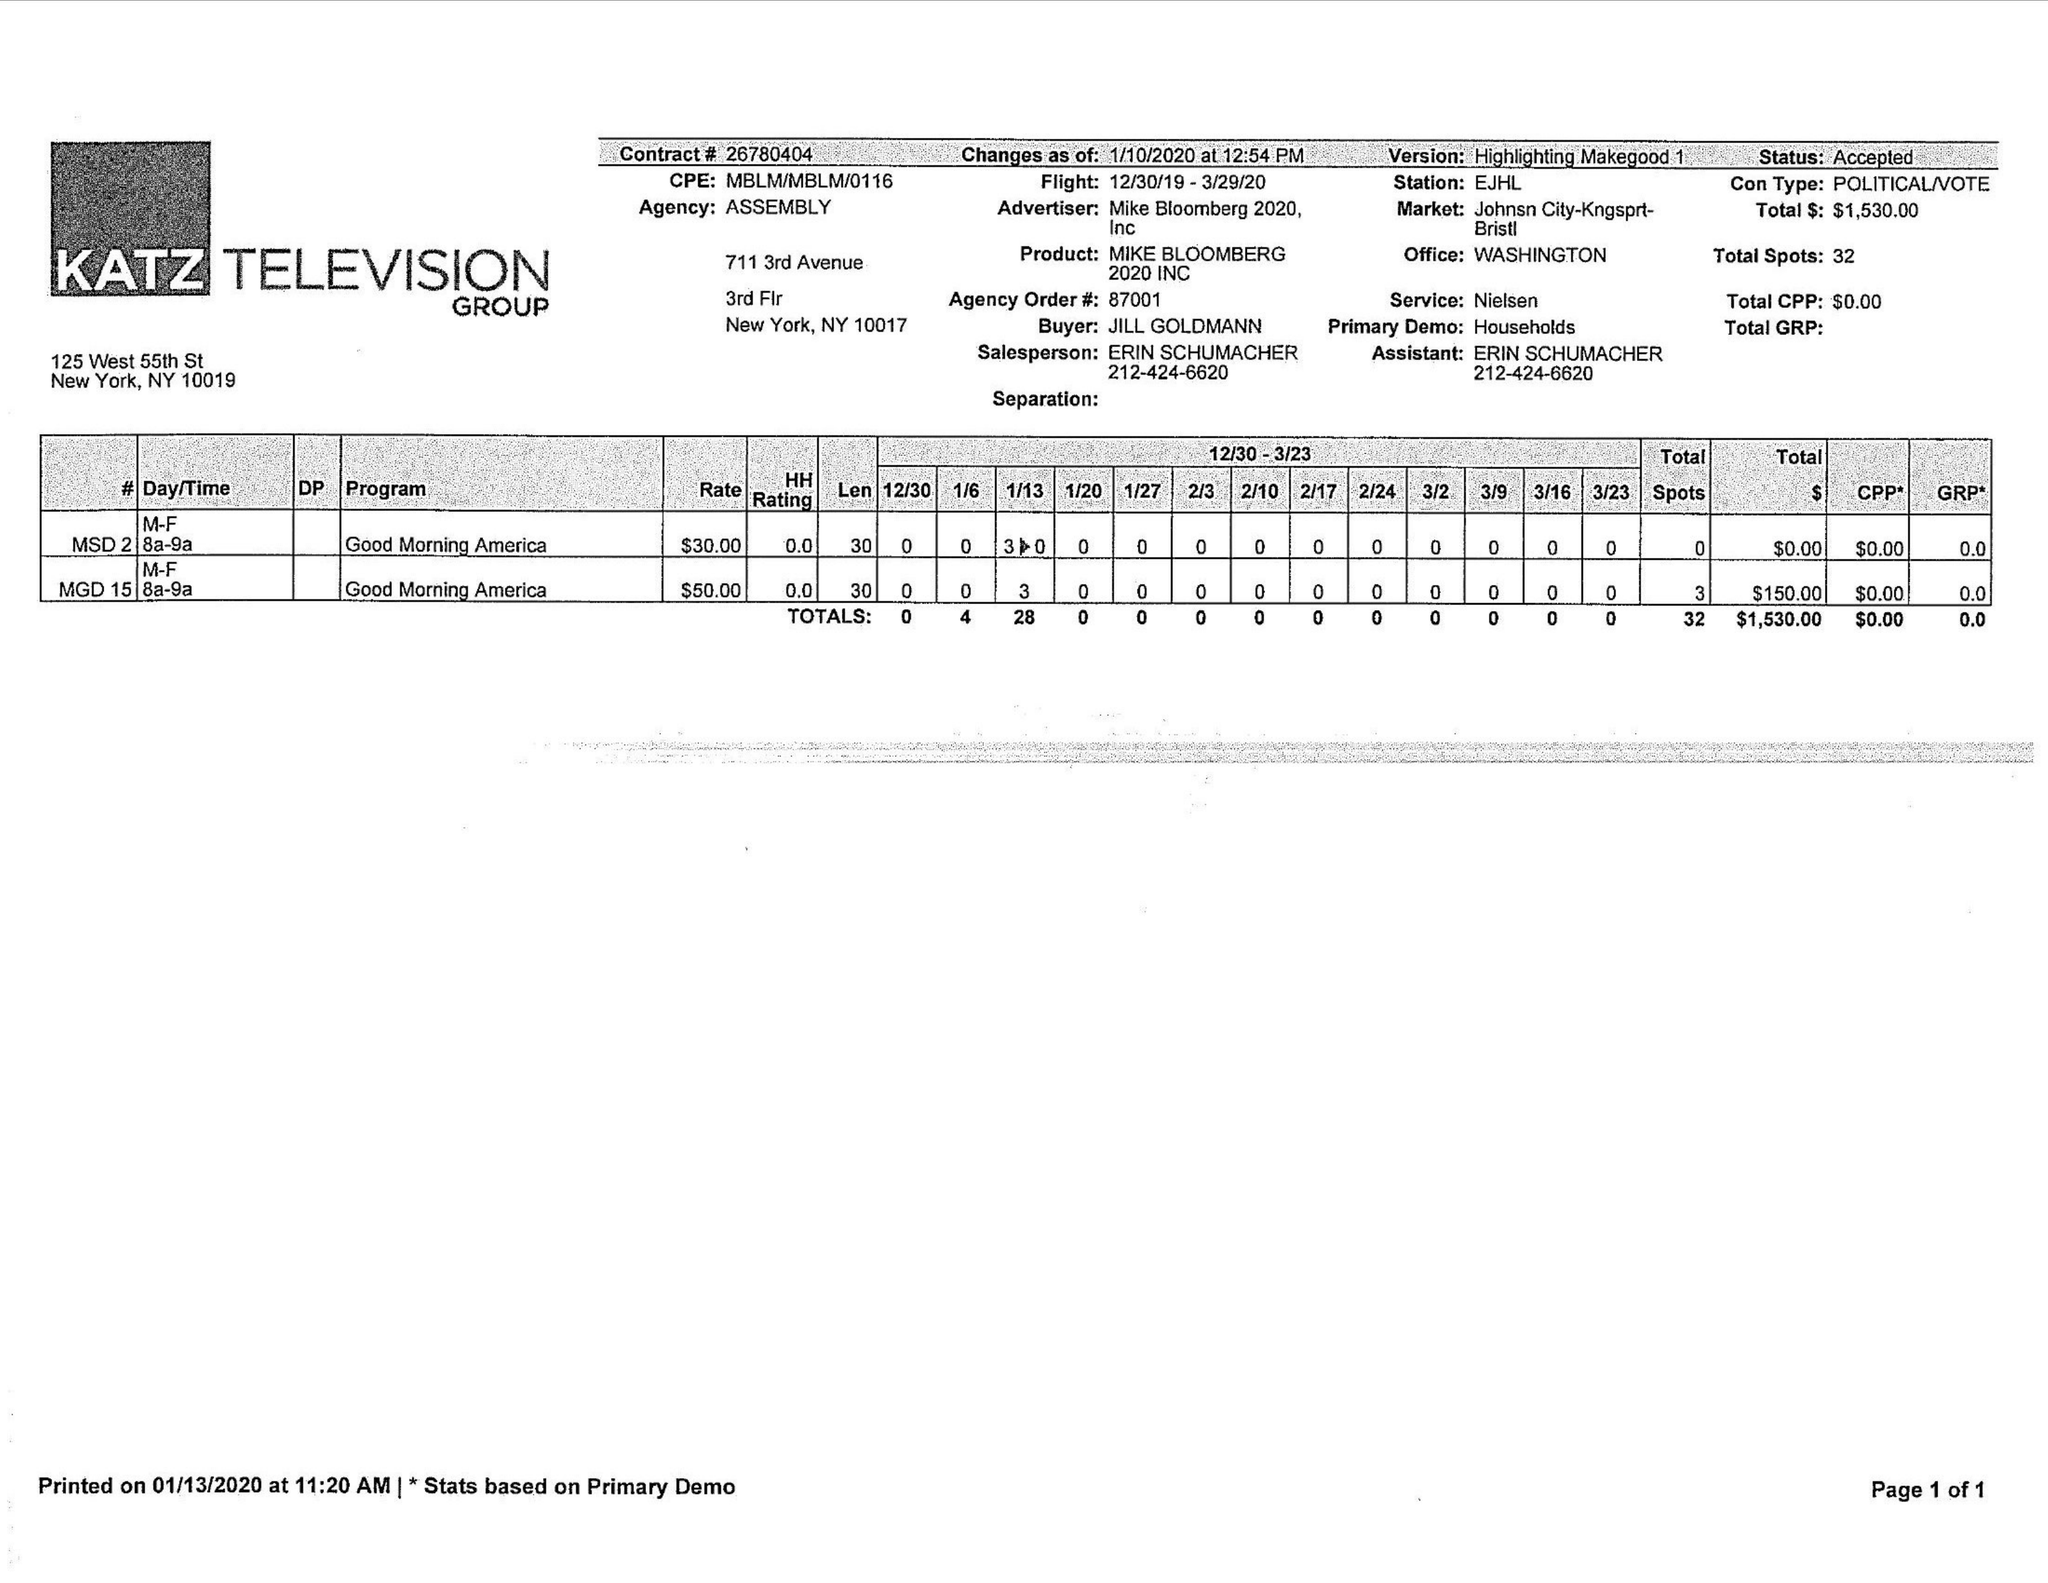What is the value for the gross_amount?
Answer the question using a single word or phrase. 1530.00 